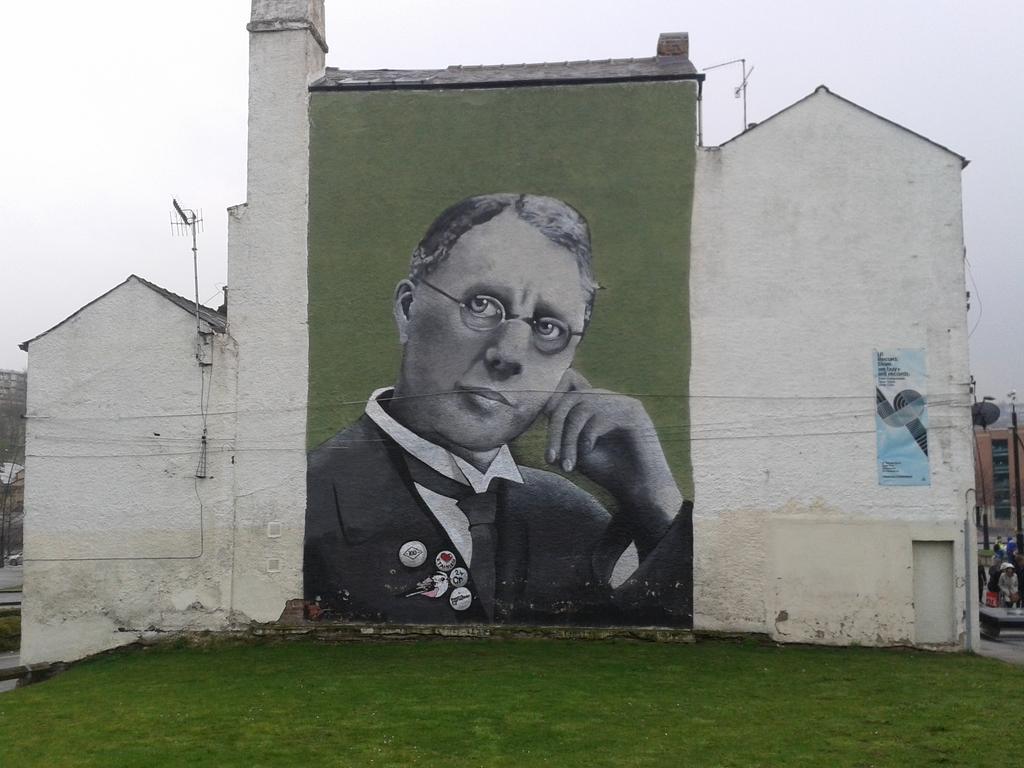In one or two sentences, can you explain what this image depicts? In this picture we can see a building here, there is a board pasted on the wall here, here we can see a painting of a person, at the bottom there is grass, we can see sky at the top of the picture, we can see an antenna here. 